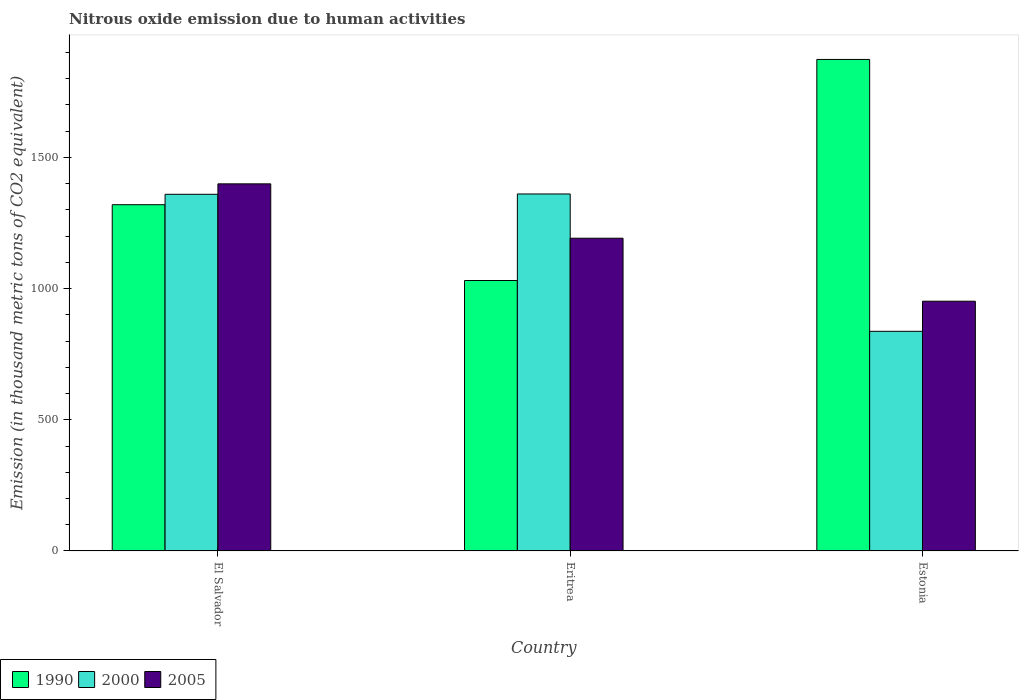How many different coloured bars are there?
Your answer should be very brief. 3. Are the number of bars per tick equal to the number of legend labels?
Ensure brevity in your answer.  Yes. Are the number of bars on each tick of the X-axis equal?
Offer a terse response. Yes. What is the label of the 2nd group of bars from the left?
Give a very brief answer. Eritrea. What is the amount of nitrous oxide emitted in 2000 in Estonia?
Your answer should be very brief. 837. Across all countries, what is the maximum amount of nitrous oxide emitted in 2005?
Offer a very short reply. 1398.9. Across all countries, what is the minimum amount of nitrous oxide emitted in 2000?
Provide a succinct answer. 837. In which country was the amount of nitrous oxide emitted in 2000 maximum?
Your answer should be very brief. Eritrea. In which country was the amount of nitrous oxide emitted in 2005 minimum?
Provide a succinct answer. Estonia. What is the total amount of nitrous oxide emitted in 2000 in the graph?
Offer a terse response. 3556.4. What is the difference between the amount of nitrous oxide emitted in 1990 in El Salvador and that in Estonia?
Offer a terse response. -553.5. What is the difference between the amount of nitrous oxide emitted in 2005 in El Salvador and the amount of nitrous oxide emitted in 1990 in Estonia?
Offer a very short reply. -474. What is the average amount of nitrous oxide emitted in 2000 per country?
Your response must be concise. 1185.47. What is the difference between the amount of nitrous oxide emitted of/in 2000 and amount of nitrous oxide emitted of/in 2005 in Estonia?
Offer a terse response. -114.7. In how many countries, is the amount of nitrous oxide emitted in 2000 greater than 300 thousand metric tons?
Your answer should be very brief. 3. What is the ratio of the amount of nitrous oxide emitted in 1990 in El Salvador to that in Eritrea?
Your answer should be compact. 1.28. What is the difference between the highest and the second highest amount of nitrous oxide emitted in 2005?
Give a very brief answer. -447.2. What is the difference between the highest and the lowest amount of nitrous oxide emitted in 2000?
Ensure brevity in your answer.  523.3. Is the sum of the amount of nitrous oxide emitted in 1990 in El Salvador and Eritrea greater than the maximum amount of nitrous oxide emitted in 2005 across all countries?
Keep it short and to the point. Yes. What does the 2nd bar from the left in El Salvador represents?
Make the answer very short. 2000. Is it the case that in every country, the sum of the amount of nitrous oxide emitted in 1990 and amount of nitrous oxide emitted in 2000 is greater than the amount of nitrous oxide emitted in 2005?
Your answer should be compact. Yes. How many countries are there in the graph?
Provide a short and direct response. 3. What is the difference between two consecutive major ticks on the Y-axis?
Your response must be concise. 500. Where does the legend appear in the graph?
Your answer should be compact. Bottom left. What is the title of the graph?
Offer a very short reply. Nitrous oxide emission due to human activities. Does "2003" appear as one of the legend labels in the graph?
Make the answer very short. No. What is the label or title of the Y-axis?
Offer a very short reply. Emission (in thousand metric tons of CO2 equivalent). What is the Emission (in thousand metric tons of CO2 equivalent) of 1990 in El Salvador?
Give a very brief answer. 1319.4. What is the Emission (in thousand metric tons of CO2 equivalent) of 2000 in El Salvador?
Provide a short and direct response. 1359.1. What is the Emission (in thousand metric tons of CO2 equivalent) of 2005 in El Salvador?
Provide a short and direct response. 1398.9. What is the Emission (in thousand metric tons of CO2 equivalent) in 1990 in Eritrea?
Provide a short and direct response. 1030.6. What is the Emission (in thousand metric tons of CO2 equivalent) in 2000 in Eritrea?
Your answer should be compact. 1360.3. What is the Emission (in thousand metric tons of CO2 equivalent) of 2005 in Eritrea?
Provide a succinct answer. 1191.7. What is the Emission (in thousand metric tons of CO2 equivalent) of 1990 in Estonia?
Offer a terse response. 1872.9. What is the Emission (in thousand metric tons of CO2 equivalent) of 2000 in Estonia?
Give a very brief answer. 837. What is the Emission (in thousand metric tons of CO2 equivalent) in 2005 in Estonia?
Offer a very short reply. 951.7. Across all countries, what is the maximum Emission (in thousand metric tons of CO2 equivalent) in 1990?
Your response must be concise. 1872.9. Across all countries, what is the maximum Emission (in thousand metric tons of CO2 equivalent) in 2000?
Your answer should be compact. 1360.3. Across all countries, what is the maximum Emission (in thousand metric tons of CO2 equivalent) of 2005?
Offer a terse response. 1398.9. Across all countries, what is the minimum Emission (in thousand metric tons of CO2 equivalent) of 1990?
Ensure brevity in your answer.  1030.6. Across all countries, what is the minimum Emission (in thousand metric tons of CO2 equivalent) in 2000?
Give a very brief answer. 837. Across all countries, what is the minimum Emission (in thousand metric tons of CO2 equivalent) in 2005?
Keep it short and to the point. 951.7. What is the total Emission (in thousand metric tons of CO2 equivalent) in 1990 in the graph?
Offer a very short reply. 4222.9. What is the total Emission (in thousand metric tons of CO2 equivalent) in 2000 in the graph?
Keep it short and to the point. 3556.4. What is the total Emission (in thousand metric tons of CO2 equivalent) of 2005 in the graph?
Provide a succinct answer. 3542.3. What is the difference between the Emission (in thousand metric tons of CO2 equivalent) of 1990 in El Salvador and that in Eritrea?
Your answer should be very brief. 288.8. What is the difference between the Emission (in thousand metric tons of CO2 equivalent) in 2005 in El Salvador and that in Eritrea?
Give a very brief answer. 207.2. What is the difference between the Emission (in thousand metric tons of CO2 equivalent) in 1990 in El Salvador and that in Estonia?
Your answer should be very brief. -553.5. What is the difference between the Emission (in thousand metric tons of CO2 equivalent) of 2000 in El Salvador and that in Estonia?
Your answer should be compact. 522.1. What is the difference between the Emission (in thousand metric tons of CO2 equivalent) in 2005 in El Salvador and that in Estonia?
Your answer should be compact. 447.2. What is the difference between the Emission (in thousand metric tons of CO2 equivalent) in 1990 in Eritrea and that in Estonia?
Your answer should be compact. -842.3. What is the difference between the Emission (in thousand metric tons of CO2 equivalent) in 2000 in Eritrea and that in Estonia?
Your answer should be compact. 523.3. What is the difference between the Emission (in thousand metric tons of CO2 equivalent) in 2005 in Eritrea and that in Estonia?
Your response must be concise. 240. What is the difference between the Emission (in thousand metric tons of CO2 equivalent) of 1990 in El Salvador and the Emission (in thousand metric tons of CO2 equivalent) of 2000 in Eritrea?
Provide a short and direct response. -40.9. What is the difference between the Emission (in thousand metric tons of CO2 equivalent) of 1990 in El Salvador and the Emission (in thousand metric tons of CO2 equivalent) of 2005 in Eritrea?
Your answer should be very brief. 127.7. What is the difference between the Emission (in thousand metric tons of CO2 equivalent) of 2000 in El Salvador and the Emission (in thousand metric tons of CO2 equivalent) of 2005 in Eritrea?
Provide a succinct answer. 167.4. What is the difference between the Emission (in thousand metric tons of CO2 equivalent) of 1990 in El Salvador and the Emission (in thousand metric tons of CO2 equivalent) of 2000 in Estonia?
Your answer should be very brief. 482.4. What is the difference between the Emission (in thousand metric tons of CO2 equivalent) of 1990 in El Salvador and the Emission (in thousand metric tons of CO2 equivalent) of 2005 in Estonia?
Keep it short and to the point. 367.7. What is the difference between the Emission (in thousand metric tons of CO2 equivalent) of 2000 in El Salvador and the Emission (in thousand metric tons of CO2 equivalent) of 2005 in Estonia?
Make the answer very short. 407.4. What is the difference between the Emission (in thousand metric tons of CO2 equivalent) of 1990 in Eritrea and the Emission (in thousand metric tons of CO2 equivalent) of 2000 in Estonia?
Your answer should be compact. 193.6. What is the difference between the Emission (in thousand metric tons of CO2 equivalent) in 1990 in Eritrea and the Emission (in thousand metric tons of CO2 equivalent) in 2005 in Estonia?
Ensure brevity in your answer.  78.9. What is the difference between the Emission (in thousand metric tons of CO2 equivalent) in 2000 in Eritrea and the Emission (in thousand metric tons of CO2 equivalent) in 2005 in Estonia?
Your response must be concise. 408.6. What is the average Emission (in thousand metric tons of CO2 equivalent) in 1990 per country?
Offer a very short reply. 1407.63. What is the average Emission (in thousand metric tons of CO2 equivalent) of 2000 per country?
Your answer should be compact. 1185.47. What is the average Emission (in thousand metric tons of CO2 equivalent) in 2005 per country?
Keep it short and to the point. 1180.77. What is the difference between the Emission (in thousand metric tons of CO2 equivalent) in 1990 and Emission (in thousand metric tons of CO2 equivalent) in 2000 in El Salvador?
Provide a short and direct response. -39.7. What is the difference between the Emission (in thousand metric tons of CO2 equivalent) in 1990 and Emission (in thousand metric tons of CO2 equivalent) in 2005 in El Salvador?
Your answer should be very brief. -79.5. What is the difference between the Emission (in thousand metric tons of CO2 equivalent) of 2000 and Emission (in thousand metric tons of CO2 equivalent) of 2005 in El Salvador?
Your response must be concise. -39.8. What is the difference between the Emission (in thousand metric tons of CO2 equivalent) in 1990 and Emission (in thousand metric tons of CO2 equivalent) in 2000 in Eritrea?
Offer a very short reply. -329.7. What is the difference between the Emission (in thousand metric tons of CO2 equivalent) of 1990 and Emission (in thousand metric tons of CO2 equivalent) of 2005 in Eritrea?
Offer a very short reply. -161.1. What is the difference between the Emission (in thousand metric tons of CO2 equivalent) in 2000 and Emission (in thousand metric tons of CO2 equivalent) in 2005 in Eritrea?
Your response must be concise. 168.6. What is the difference between the Emission (in thousand metric tons of CO2 equivalent) in 1990 and Emission (in thousand metric tons of CO2 equivalent) in 2000 in Estonia?
Keep it short and to the point. 1035.9. What is the difference between the Emission (in thousand metric tons of CO2 equivalent) in 1990 and Emission (in thousand metric tons of CO2 equivalent) in 2005 in Estonia?
Make the answer very short. 921.2. What is the difference between the Emission (in thousand metric tons of CO2 equivalent) in 2000 and Emission (in thousand metric tons of CO2 equivalent) in 2005 in Estonia?
Offer a very short reply. -114.7. What is the ratio of the Emission (in thousand metric tons of CO2 equivalent) of 1990 in El Salvador to that in Eritrea?
Your answer should be very brief. 1.28. What is the ratio of the Emission (in thousand metric tons of CO2 equivalent) of 2000 in El Salvador to that in Eritrea?
Your answer should be very brief. 1. What is the ratio of the Emission (in thousand metric tons of CO2 equivalent) of 2005 in El Salvador to that in Eritrea?
Ensure brevity in your answer.  1.17. What is the ratio of the Emission (in thousand metric tons of CO2 equivalent) of 1990 in El Salvador to that in Estonia?
Offer a very short reply. 0.7. What is the ratio of the Emission (in thousand metric tons of CO2 equivalent) in 2000 in El Salvador to that in Estonia?
Ensure brevity in your answer.  1.62. What is the ratio of the Emission (in thousand metric tons of CO2 equivalent) in 2005 in El Salvador to that in Estonia?
Provide a short and direct response. 1.47. What is the ratio of the Emission (in thousand metric tons of CO2 equivalent) of 1990 in Eritrea to that in Estonia?
Your answer should be very brief. 0.55. What is the ratio of the Emission (in thousand metric tons of CO2 equivalent) of 2000 in Eritrea to that in Estonia?
Your answer should be very brief. 1.63. What is the ratio of the Emission (in thousand metric tons of CO2 equivalent) of 2005 in Eritrea to that in Estonia?
Ensure brevity in your answer.  1.25. What is the difference between the highest and the second highest Emission (in thousand metric tons of CO2 equivalent) of 1990?
Offer a very short reply. 553.5. What is the difference between the highest and the second highest Emission (in thousand metric tons of CO2 equivalent) in 2005?
Make the answer very short. 207.2. What is the difference between the highest and the lowest Emission (in thousand metric tons of CO2 equivalent) of 1990?
Your answer should be very brief. 842.3. What is the difference between the highest and the lowest Emission (in thousand metric tons of CO2 equivalent) in 2000?
Ensure brevity in your answer.  523.3. What is the difference between the highest and the lowest Emission (in thousand metric tons of CO2 equivalent) in 2005?
Provide a succinct answer. 447.2. 